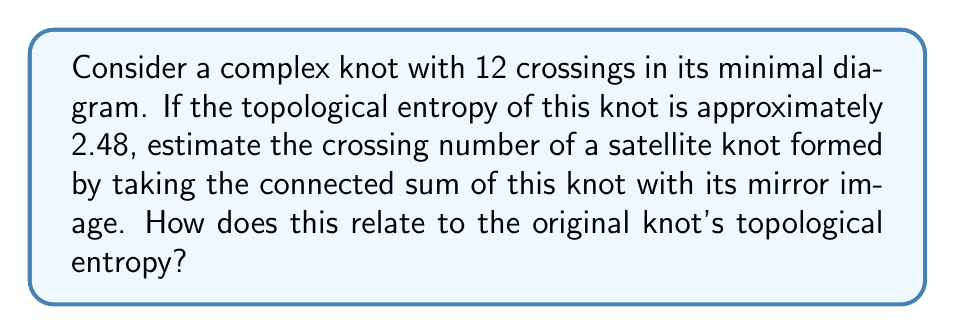Solve this math problem. Let's approach this step-by-step:

1) The original knot has a crossing number of 12 in its minimal diagram.

2) The topological entropy of a knot is related to its crossing number. For a knot $K$ with crossing number $c(K)$, the topological entropy $h(K)$ is approximately given by:

   $$h(K) \approx \ln(c(K))$$

3) In this case, we have:

   $$2.48 \approx \ln(12)$$

   Which is indeed correct (ln(12) ≈ 2.4849).

4) When we form a satellite knot by taking the connected sum of a knot with its mirror image, we effectively double the complexity. The crossing number of the resulting knot is at least twice that of the original knot:

   $$c(K \# \text{mirror}(K)) \geq 2c(K)$$

5) Therefore, the crossing number of the satellite knot is at least:

   $$c(\text{satellite}) \geq 2 * 12 = 24$$

6) The topological entropy of the satellite knot can be estimated:

   $$h(\text{satellite}) \approx \ln(24) \approx 3.18$$

7) Comparing this to the original knot's entropy:

   $$3.18 - 2.48 = 0.70$$

   This difference represents the increase in complexity due to the connected sum operation.

8) The relationship between the crossing numbers and topological entropies can be expressed as:

   $$\frac{h(\text{satellite})}{h(K)} \approx \frac{\ln(2c(K))}{\ln(c(K))} = 1 + \frac{\ln(2)}{\ln(c(K))}$$

   This ratio approaches 1 as $c(K)$ increases, showing that the relative increase in complexity diminishes for more complex knots.
Answer: $c(\text{satellite}) \geq 24$; $h(\text{satellite}) \approx 3.18$; $\frac{h(\text{satellite})}{h(K)} \approx 1.28$ 